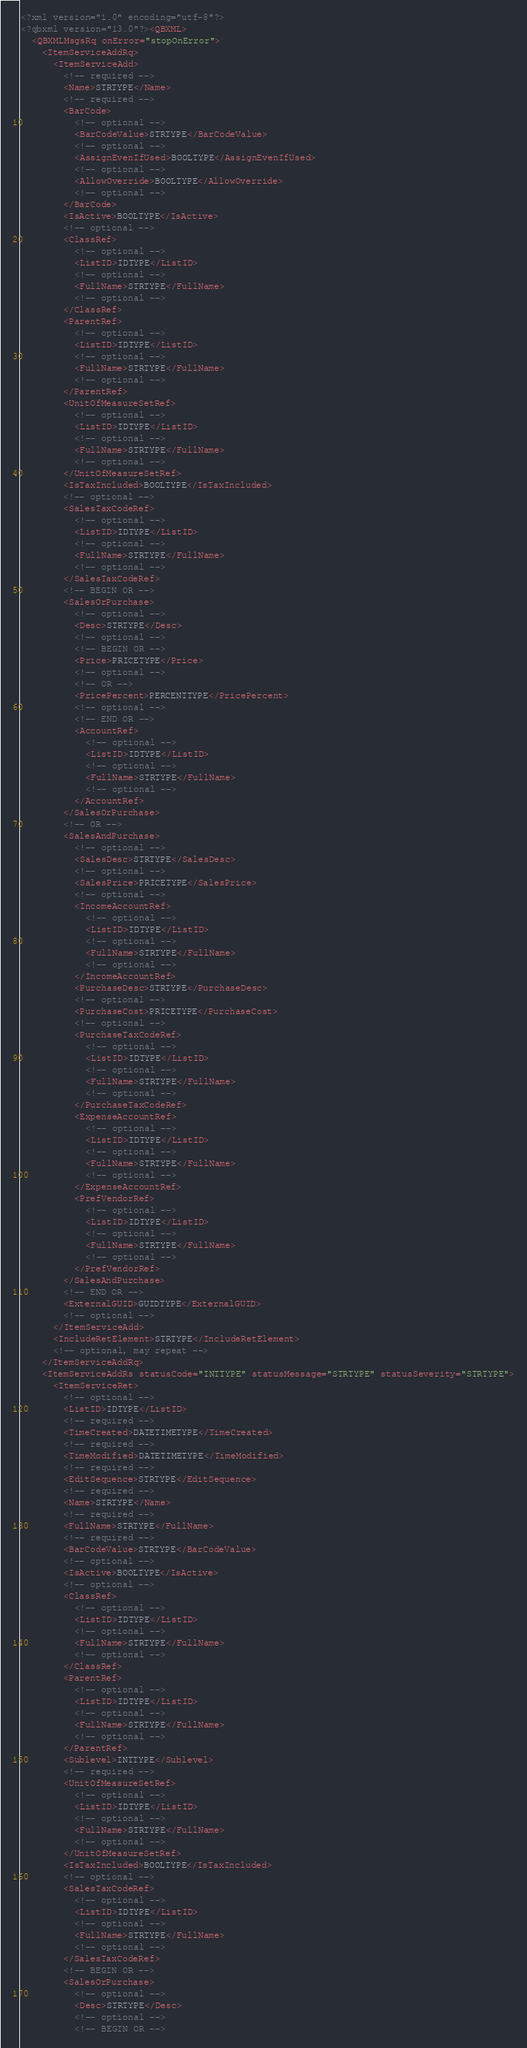<code> <loc_0><loc_0><loc_500><loc_500><_XML_><?xml version="1.0" encoding="utf-8"?>
<?qbxml version="13.0"?><QBXML>
  <QBXMLMsgsRq onError="stopOnError">
    <ItemServiceAddRq>
      <ItemServiceAdd>
        <!-- required -->
        <Name>STRTYPE</Name>
        <!-- required -->
        <BarCode>
          <!-- optional -->
          <BarCodeValue>STRTYPE</BarCodeValue>
          <!-- optional -->
          <AssignEvenIfUsed>BOOLTYPE</AssignEvenIfUsed>
          <!-- optional -->
          <AllowOverride>BOOLTYPE</AllowOverride>
          <!-- optional -->
        </BarCode>
        <IsActive>BOOLTYPE</IsActive>
        <!-- optional -->
        <ClassRef>
          <!-- optional -->
          <ListID>IDTYPE</ListID>
          <!-- optional -->
          <FullName>STRTYPE</FullName>
          <!-- optional -->
        </ClassRef>
        <ParentRef>
          <!-- optional -->
          <ListID>IDTYPE</ListID>
          <!-- optional -->
          <FullName>STRTYPE</FullName>
          <!-- optional -->
        </ParentRef>
        <UnitOfMeasureSetRef>
          <!-- optional -->
          <ListID>IDTYPE</ListID>
          <!-- optional -->
          <FullName>STRTYPE</FullName>
          <!-- optional -->
        </UnitOfMeasureSetRef>
        <IsTaxIncluded>BOOLTYPE</IsTaxIncluded>
        <!-- optional -->
        <SalesTaxCodeRef>
          <!-- optional -->
          <ListID>IDTYPE</ListID>
          <!-- optional -->
          <FullName>STRTYPE</FullName>
          <!-- optional -->
        </SalesTaxCodeRef>
        <!-- BEGIN OR -->
        <SalesOrPurchase>
          <!-- optional -->
          <Desc>STRTYPE</Desc>
          <!-- optional -->
          <!-- BEGIN OR -->
          <Price>PRICETYPE</Price>
          <!-- optional -->
          <!-- OR -->
          <PricePercent>PERCENTTYPE</PricePercent>
          <!-- optional -->
          <!-- END OR -->
          <AccountRef>
            <!-- optional -->
            <ListID>IDTYPE</ListID>
            <!-- optional -->
            <FullName>STRTYPE</FullName>
            <!-- optional -->
          </AccountRef>
        </SalesOrPurchase>
        <!-- OR -->
        <SalesAndPurchase>
          <!-- optional -->
          <SalesDesc>STRTYPE</SalesDesc>
          <!-- optional -->
          <SalesPrice>PRICETYPE</SalesPrice>
          <!-- optional -->
          <IncomeAccountRef>
            <!-- optional -->
            <ListID>IDTYPE</ListID>
            <!-- optional -->
            <FullName>STRTYPE</FullName>
            <!-- optional -->
          </IncomeAccountRef>
          <PurchaseDesc>STRTYPE</PurchaseDesc>
          <!-- optional -->
          <PurchaseCost>PRICETYPE</PurchaseCost>
          <!-- optional -->
          <PurchaseTaxCodeRef>
            <!-- optional -->
            <ListID>IDTYPE</ListID>
            <!-- optional -->
            <FullName>STRTYPE</FullName>
            <!-- optional -->
          </PurchaseTaxCodeRef>
          <ExpenseAccountRef>
            <!-- optional -->
            <ListID>IDTYPE</ListID>
            <!-- optional -->
            <FullName>STRTYPE</FullName>
            <!-- optional -->
          </ExpenseAccountRef>
          <PrefVendorRef>
            <!-- optional -->
            <ListID>IDTYPE</ListID>
            <!-- optional -->
            <FullName>STRTYPE</FullName>
            <!-- optional -->
          </PrefVendorRef>
        </SalesAndPurchase>
        <!-- END OR -->
        <ExternalGUID>GUIDTYPE</ExternalGUID>
        <!-- optional -->
      </ItemServiceAdd>
      <IncludeRetElement>STRTYPE</IncludeRetElement>
      <!-- optional, may repeat -->
    </ItemServiceAddRq>
    <ItemServiceAddRs statusCode="INTTYPE" statusMessage="STRTYPE" statusSeverity="STRTYPE">
      <ItemServiceRet>
        <!-- optional -->
        <ListID>IDTYPE</ListID>
        <!-- required -->
        <TimeCreated>DATETIMETYPE</TimeCreated>
        <!-- required -->
        <TimeModified>DATETIMETYPE</TimeModified>
        <!-- required -->
        <EditSequence>STRTYPE</EditSequence>
        <!-- required -->
        <Name>STRTYPE</Name>
        <!-- required -->
        <FullName>STRTYPE</FullName>
        <!-- required -->
        <BarCodeValue>STRTYPE</BarCodeValue>
        <!-- optional -->
        <IsActive>BOOLTYPE</IsActive>
        <!-- optional -->
        <ClassRef>
          <!-- optional -->
          <ListID>IDTYPE</ListID>
          <!-- optional -->
          <FullName>STRTYPE</FullName>
          <!-- optional -->
        </ClassRef>
        <ParentRef>
          <!-- optional -->
          <ListID>IDTYPE</ListID>
          <!-- optional -->
          <FullName>STRTYPE</FullName>
          <!-- optional -->
        </ParentRef>
        <Sublevel>INTTYPE</Sublevel>
        <!-- required -->
        <UnitOfMeasureSetRef>
          <!-- optional -->
          <ListID>IDTYPE</ListID>
          <!-- optional -->
          <FullName>STRTYPE</FullName>
          <!-- optional -->
        </UnitOfMeasureSetRef>
        <IsTaxIncluded>BOOLTYPE</IsTaxIncluded>
        <!-- optional -->
        <SalesTaxCodeRef>
          <!-- optional -->
          <ListID>IDTYPE</ListID>
          <!-- optional -->
          <FullName>STRTYPE</FullName>
          <!-- optional -->
        </SalesTaxCodeRef>
        <!-- BEGIN OR -->
        <SalesOrPurchase>
          <!-- optional -->
          <Desc>STRTYPE</Desc>
          <!-- optional -->
          <!-- BEGIN OR --></code> 